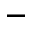Convert formula to latex. <formula><loc_0><loc_0><loc_500><loc_500>^ { - }</formula> 